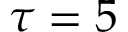Convert formula to latex. <formula><loc_0><loc_0><loc_500><loc_500>\tau = 5</formula> 